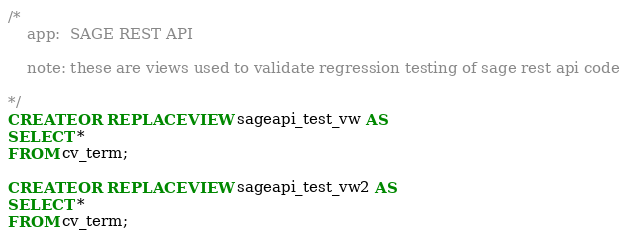Convert code to text. <code><loc_0><loc_0><loc_500><loc_500><_SQL_>/* 
    app:  SAGE REST API
    
    note: these are views used to validate regression testing of sage rest api code

*/
CREATE OR REPLACE VIEW sageapi_test_vw AS
SELECT *
FROM cv_term;

CREATE OR REPLACE VIEW sageapi_test_vw2 AS
SELECT * 
FROM cv_term;
</code> 